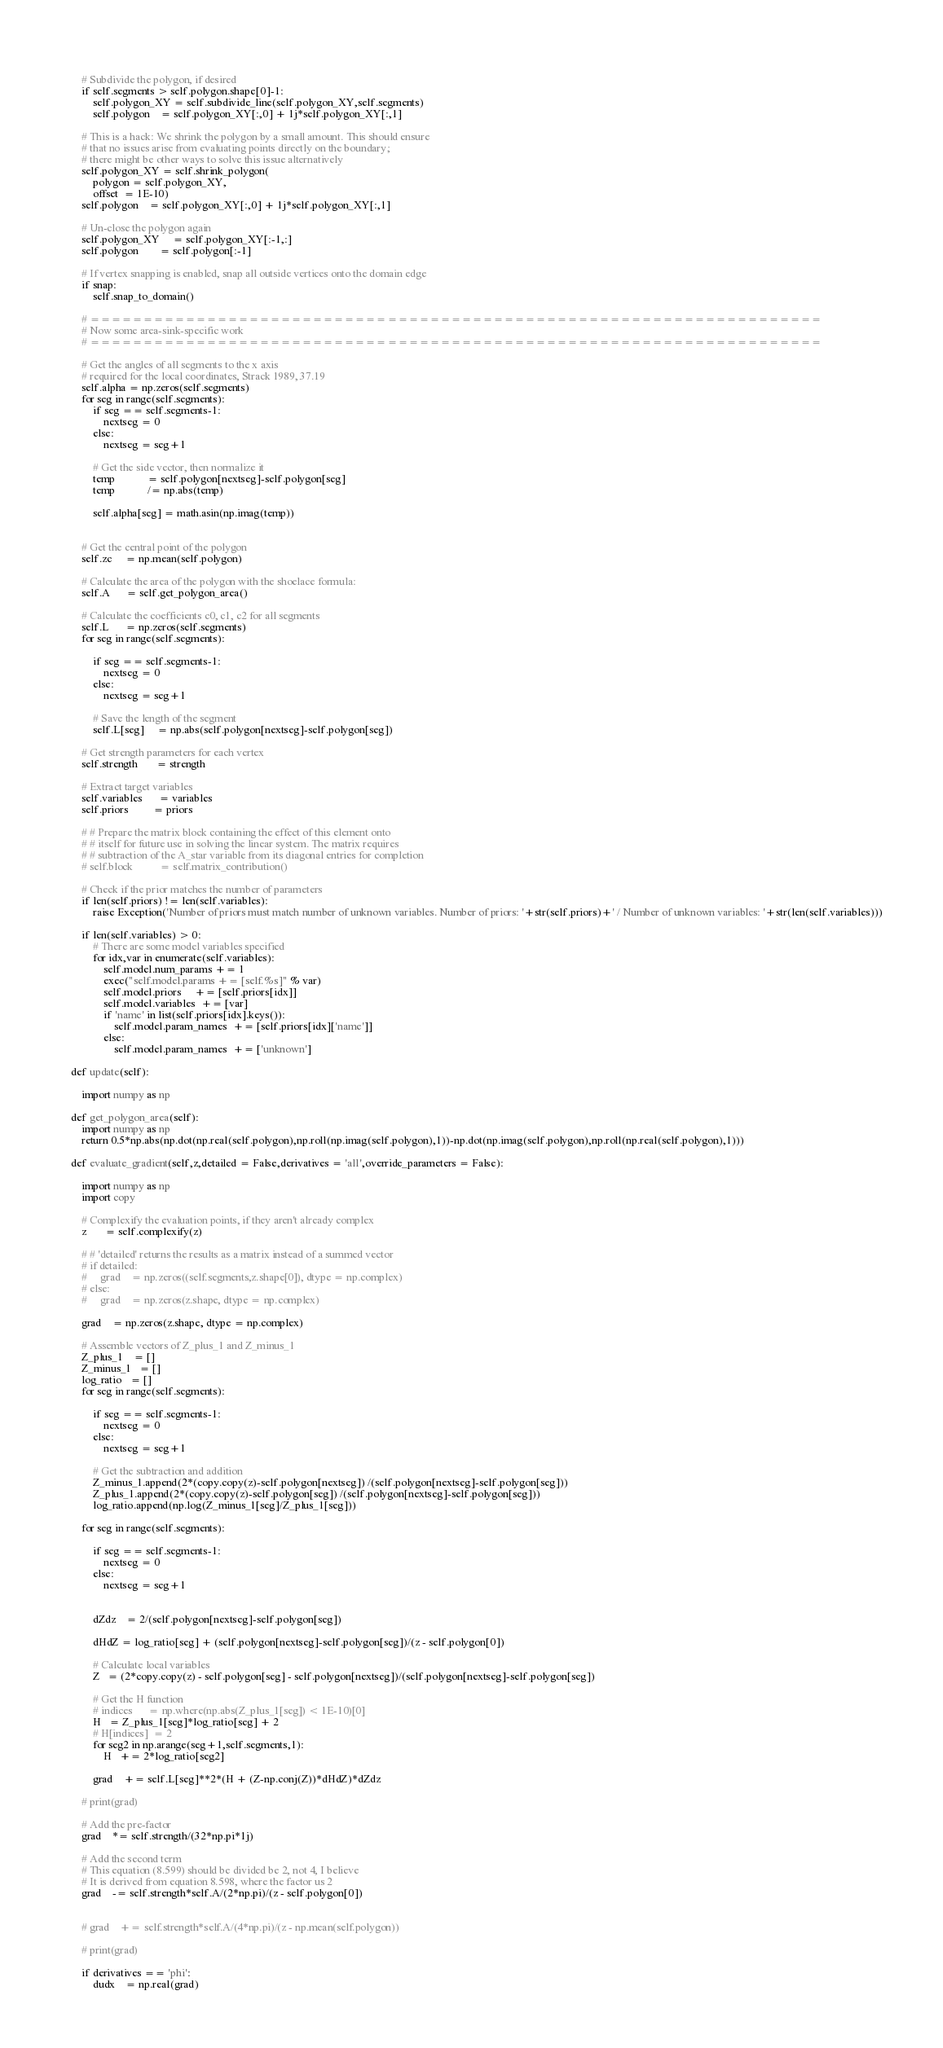<code> <loc_0><loc_0><loc_500><loc_500><_Python_>        
        # Subdivide the polygon, if desired
        if self.segments > self.polygon.shape[0]-1:
            self.polygon_XY = self.subdivide_line(self.polygon_XY,self.segments)
            self.polygon    = self.polygon_XY[:,0] + 1j*self.polygon_XY[:,1]
            
        # This is a hack: We shrink the polygon by a small amount. This should ensure 
        # that no issues arise from evaluating points directly on the boundary; 
        # there might be other ways to solve this issue alternatively
        self.polygon_XY = self.shrink_polygon(
            polygon = self.polygon_XY,
            offset  = 1E-10)
        self.polygon    = self.polygon_XY[:,0] + 1j*self.polygon_XY[:,1]
            
        # Un-close the polygon again
        self.polygon_XY     = self.polygon_XY[:-1,:]
        self.polygon        = self.polygon[:-1]
            
        # If vertex snapping is enabled, snap all outside vertices onto the domain edge
        if snap:
            self.snap_to_domain()
            
        # =====================================================================
        # Now some area-sink-specific work
        # =====================================================================
        
        # Get the angles of all segments to the x axis
        # required for the local coordinates, Strack 1989, 37.19
        self.alpha = np.zeros(self.segments)
        for seg in range(self.segments):
            if seg == self.segments-1:
                nextseg = 0
            else:
                nextseg = seg+1
            
            # Get the side vector, then normalize it    
            temp            = self.polygon[nextseg]-self.polygon[seg]
            temp            /= np.abs(temp)
            
            self.alpha[seg] = math.asin(np.imag(temp))
            
        
        # Get the central point of the polygon
        self.zc     = np.mean(self.polygon)
            
        # Calculate the area of the polygon with the shoelace formula:
        self.A      = self.get_polygon_area()
            
        # Calculate the coefficients c0, c1, c2 for all segments
        self.L      = np.zeros(self.segments)
        for seg in range(self.segments):
            
            if seg == self.segments-1:
                nextseg = 0
            else:
                nextseg = seg+1
            
            # Save the length of the segment
            self.L[seg]     = np.abs(self.polygon[nextseg]-self.polygon[seg])
        
        # Get strength parameters for each vertex
        self.strength       = strength
        
        # Extract target variables
        self.variables      = variables
        self.priors         = priors
        
        # # Prepare the matrix block containing the effect of this element onto 
        # # itself for future use in solving the linear system. The matrix requires
        # # subtraction of the A_star variable from its diagonal entries for completion
        # self.block          = self.matrix_contribution()
        
        # Check if the prior matches the number of parameters
        if len(self.priors) != len(self.variables):
            raise Exception('Number of priors must match number of unknown variables. Number of priors: '+str(self.priors)+' / Number of unknown variables: '+str(len(self.variables)))
        
        if len(self.variables) > 0:
            # There are some model variables specified
            for idx,var in enumerate(self.variables):
                self.model.num_params += 1
                exec("self.model.params += [self.%s]" % var)
                self.model.priors     += [self.priors[idx]]
                self.model.variables  += [var]
                if 'name' in list(self.priors[idx].keys()):
                    self.model.param_names  += [self.priors[idx]['name']]   
                else:                       
                    self.model.param_names  += ['unknown']   
                    
    def update(self):
        
        import numpy as np
        
    def get_polygon_area(self):
        import numpy as np
        return 0.5*np.abs(np.dot(np.real(self.polygon),np.roll(np.imag(self.polygon),1))-np.dot(np.imag(self.polygon),np.roll(np.real(self.polygon),1)))
        
    def evaluate_gradient(self,z,detailed = False,derivatives = 'all',override_parameters = False):
        
        import numpy as np
        import copy
        
        # Complexify the evaluation points, if they aren't already complex
        z       = self.complexify(z)
        
        # # 'detailed' returns the results as a matrix instead of a summed vector
        # if detailed:
        #     grad    = np.zeros((self.segments,z.shape[0]), dtype = np.complex)
        # else:
        #     grad    = np.zeros(z.shape, dtype = np.complex)
        
        grad    = np.zeros(z.shape, dtype = np.complex)
        
        # Assemble vectors of Z_plus_1 and Z_minus_1
        Z_plus_1    = []
        Z_minus_1   = []
        log_ratio   = []
        for seg in range(self.segments):
            
            if seg == self.segments-1:
                nextseg = 0
            else:
                nextseg = seg+1
            
            # Get the subtraction and addition
            Z_minus_1.append(2*(copy.copy(z)-self.polygon[nextseg]) /(self.polygon[nextseg]-self.polygon[seg]))
            Z_plus_1.append(2*(copy.copy(z)-self.polygon[seg]) /(self.polygon[nextseg]-self.polygon[seg]))
            log_ratio.append(np.log(Z_minus_1[seg]/Z_plus_1[seg]))
            
        for seg in range(self.segments):
            
            if seg == self.segments-1:
                nextseg = 0
            else:
                nextseg = seg+1
            
                
            dZdz    = 2/(self.polygon[nextseg]-self.polygon[seg])
            
            dHdZ = log_ratio[seg] + (self.polygon[nextseg]-self.polygon[seg])/(z - self.polygon[0])
            
            # Calculate local variables
            Z   = (2*copy.copy(z) - self.polygon[seg] - self.polygon[nextseg])/(self.polygon[nextseg]-self.polygon[seg])
            
            # Get the H function
            # indices      = np.where(np.abs(Z_plus_1[seg]) < 1E-10)[0]
            H   = Z_plus_1[seg]*log_ratio[seg] + 2
            # H[indices]  = 2
            for seg2 in np.arange(seg+1,self.segments,1):
                H   += 2*log_ratio[seg2]
                
            grad    += self.L[seg]**2*(H + (Z-np.conj(Z))*dHdZ)*dZdz
            
        # print(grad)
        
        # Add the pre-factor
        grad    *= self.strength/(32*np.pi*1j)
        
        # Add the second term
        # This equation (8.599) should be divided be 2, not 4, I believe
        # It is derived from equation 8.598, where the factor us 2
        grad    -= self.strength*self.A/(2*np.pi)/(z - self.polygon[0])
        
        
        # grad    += self.strength*self.A/(4*np.pi)/(z - np.mean(self.polygon))
        
        # print(grad)
        
        if derivatives == 'phi':
            dudx    = np.real(grad)</code> 